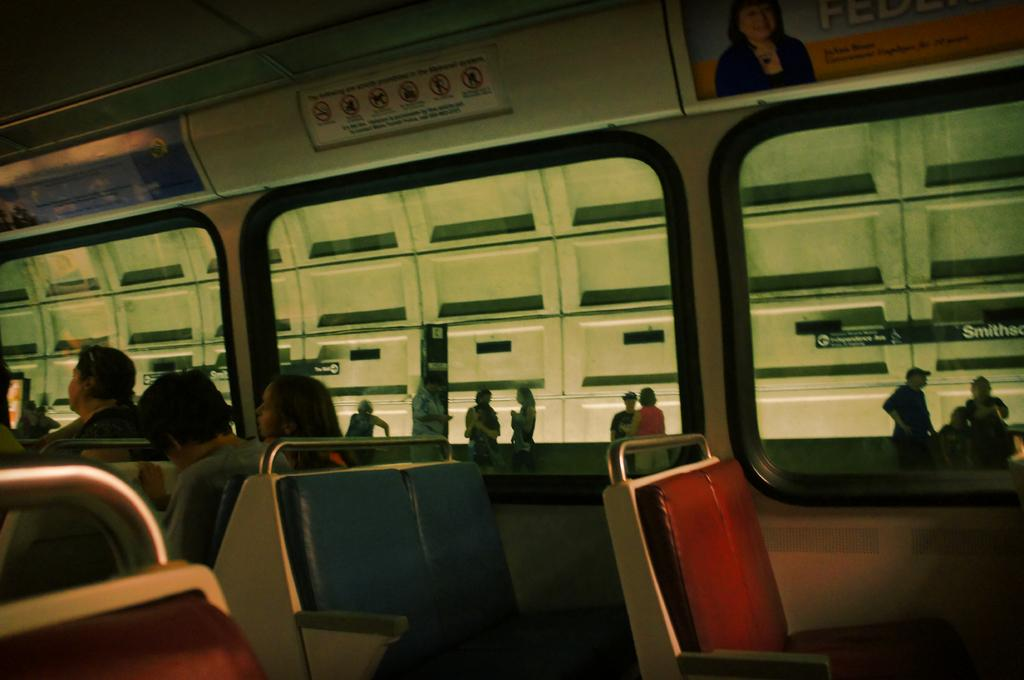What is happening in the image involving the people and the vehicle? There are people seated in a vehicle and people standing outside the vehicle. Can you describe the surroundings of the vehicle? There are hoardings visible in the image. What type of wilderness can be seen in the background of the image? There is no wilderness visible in the image; it features a vehicle with people inside and outside, as well as hoardings. Can you tell me how many scarecrows are present in the image? There are no scarecrows present in the image. 